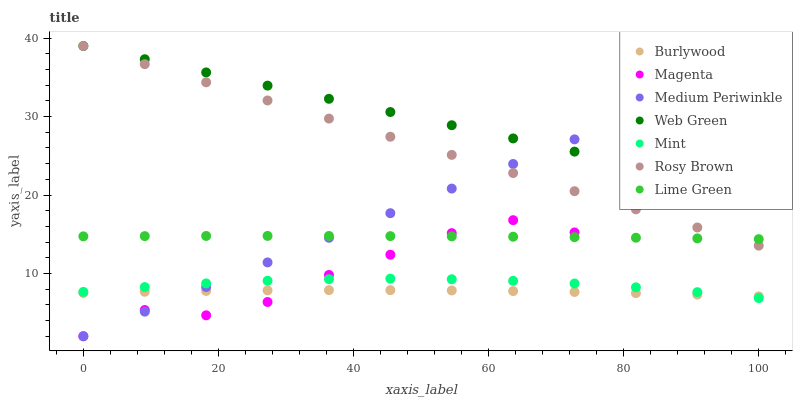Does Burlywood have the minimum area under the curve?
Answer yes or no. Yes. Does Web Green have the maximum area under the curve?
Answer yes or no. Yes. Does Lime Green have the minimum area under the curve?
Answer yes or no. No. Does Lime Green have the maximum area under the curve?
Answer yes or no. No. Is Rosy Brown the smoothest?
Answer yes or no. Yes. Is Magenta the roughest?
Answer yes or no. Yes. Is Lime Green the smoothest?
Answer yes or no. No. Is Lime Green the roughest?
Answer yes or no. No. Does Medium Periwinkle have the lowest value?
Answer yes or no. Yes. Does Lime Green have the lowest value?
Answer yes or no. No. Does Web Green have the highest value?
Answer yes or no. Yes. Does Lime Green have the highest value?
Answer yes or no. No. Is Mint less than Lime Green?
Answer yes or no. Yes. Is Rosy Brown greater than Mint?
Answer yes or no. Yes. Does Rosy Brown intersect Lime Green?
Answer yes or no. Yes. Is Rosy Brown less than Lime Green?
Answer yes or no. No. Is Rosy Brown greater than Lime Green?
Answer yes or no. No. Does Mint intersect Lime Green?
Answer yes or no. No. 